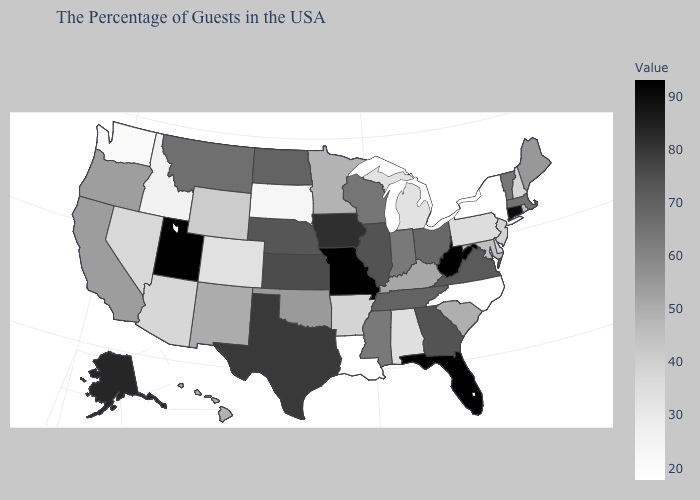Among the states that border Utah , does Idaho have the lowest value?
Short answer required. Yes. Among the states that border Massachusetts , does New York have the highest value?
Short answer required. No. Does Louisiana have the lowest value in the USA?
Be succinct. Yes. Does North Carolina have the lowest value in the USA?
Give a very brief answer. Yes. Does Oregon have the highest value in the USA?
Concise answer only. No. Does the map have missing data?
Quick response, please. No. Among the states that border Missouri , does Arkansas have the lowest value?
Write a very short answer. Yes. Does Wyoming have a lower value than Michigan?
Be succinct. No. 